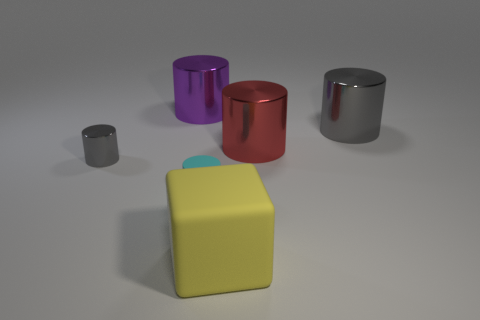There is another metal cylinder that is the same color as the tiny shiny cylinder; what size is it?
Provide a succinct answer. Large. Is the number of cylinders that are to the left of the rubber block less than the number of objects that are behind the cyan thing?
Your answer should be very brief. Yes. What is the color of the rubber cylinder?
Keep it short and to the point. Cyan. Is there a shiny ball that has the same color as the block?
Provide a short and direct response. No. There is a big yellow thing in front of the gray metal object that is right of the big yellow block in front of the small gray object; what shape is it?
Ensure brevity in your answer.  Cube. What is the material of the gray thing to the right of the large yellow thing?
Give a very brief answer. Metal. There is a gray cylinder left of the gray shiny cylinder that is right of the gray thing on the left side of the red thing; how big is it?
Offer a very short reply. Small. Is the size of the yellow block the same as the gray metallic cylinder that is to the right of the tiny metal object?
Offer a terse response. Yes. What is the color of the big metal cylinder that is to the left of the large red thing?
Your response must be concise. Purple. What is the shape of the big thing that is the same color as the small shiny thing?
Ensure brevity in your answer.  Cylinder. 